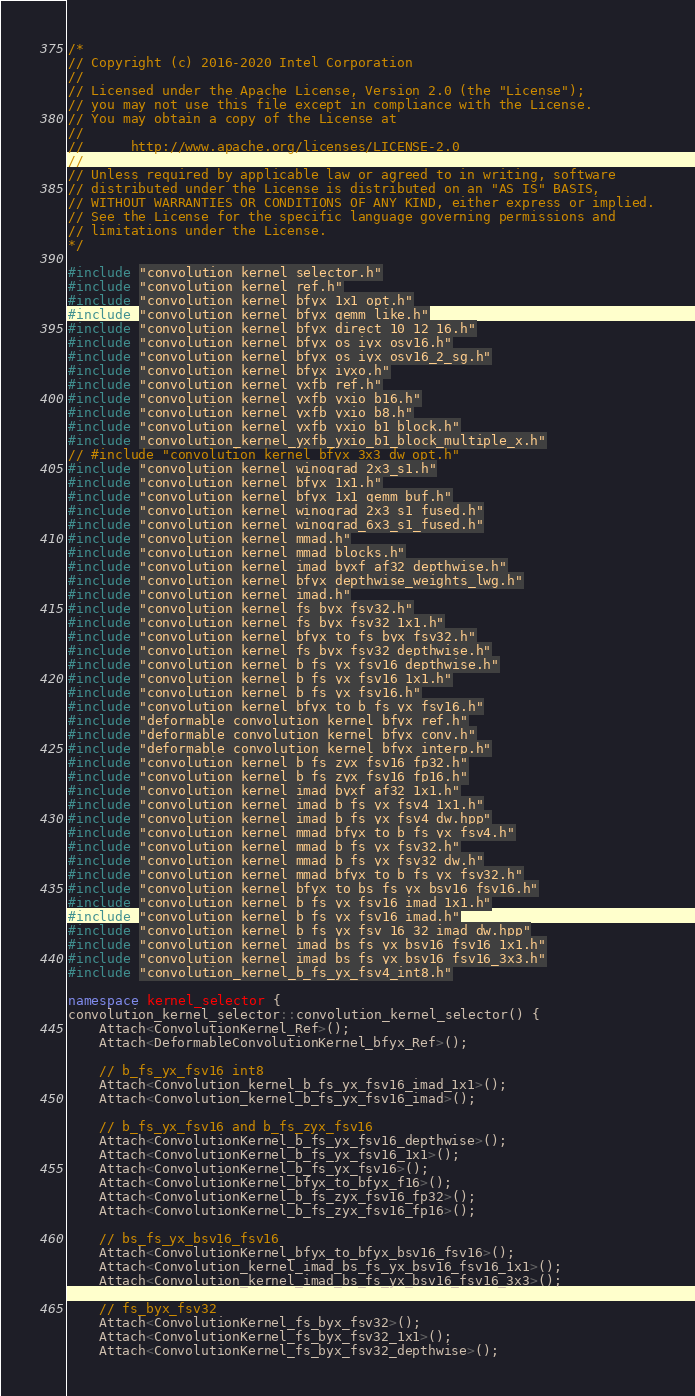Convert code to text. <code><loc_0><loc_0><loc_500><loc_500><_C++_>/*
// Copyright (c) 2016-2020 Intel Corporation
//
// Licensed under the Apache License, Version 2.0 (the "License");
// you may not use this file except in compliance with the License.
// You may obtain a copy of the License at
//
//      http://www.apache.org/licenses/LICENSE-2.0
//
// Unless required by applicable law or agreed to in writing, software
// distributed under the License is distributed on an "AS IS" BASIS,
// WITHOUT WARRANTIES OR CONDITIONS OF ANY KIND, either express or implied.
// See the License for the specific language governing permissions and
// limitations under the License.
*/

#include "convolution_kernel_selector.h"
#include "convolution_kernel_ref.h"
#include "convolution_kernel_bfyx_1x1_opt.h"
#include "convolution_kernel_bfyx_gemm_like.h"
#include "convolution_kernel_bfyx_direct_10_12_16.h"
#include "convolution_kernel_bfyx_os_iyx_osv16.h"
#include "convolution_kernel_bfyx_os_iyx_osv16_2_sg.h"
#include "convolution_kernel_bfyx_iyxo.h"
#include "convolution_kernel_yxfb_ref.h"
#include "convolution_kernel_yxfb_yxio_b16.h"
#include "convolution_kernel_yxfb_yxio_b8.h"
#include "convolution_kernel_yxfb_yxio_b1_block.h"
#include "convolution_kernel_yxfb_yxio_b1_block_multiple_x.h"
// #include "convolution_kernel_bfyx_3x3_dw_opt.h"
#include "convolution_kernel_winograd_2x3_s1.h"
#include "convolution_kernel_bfyx_1x1.h"
#include "convolution_kernel_bfyx_1x1_gemm_buf.h"
#include "convolution_kernel_winograd_2x3_s1_fused.h"
#include "convolution_kernel_winograd_6x3_s1_fused.h"
#include "convolution_kernel_mmad.h"
#include "convolution_kernel_mmad_blocks.h"
#include "convolution_kernel_imad_byxf_af32_depthwise.h"
#include "convolution_kernel_bfyx_depthwise_weights_lwg.h"
#include "convolution_kernel_imad.h"
#include "convolution_kernel_fs_byx_fsv32.h"
#include "convolution_kernel_fs_byx_fsv32_1x1.h"
#include "convolution_kernel_bfyx_to_fs_byx_fsv32.h"
#include "convolution_kernel_fs_byx_fsv32_depthwise.h"
#include "convolution_kernel_b_fs_yx_fsv16_depthwise.h"
#include "convolution_kernel_b_fs_yx_fsv16_1x1.h"
#include "convolution_kernel_b_fs_yx_fsv16.h"
#include "convolution_kernel_bfyx_to_b_fs_yx_fsv16.h"
#include "deformable_convolution_kernel_bfyx_ref.h"
#include "deformable_convolution_kernel_bfyx_conv.h"
#include "deformable_convolution_kernel_bfyx_interp.h"
#include "convolution_kernel_b_fs_zyx_fsv16_fp32.h"
#include "convolution_kernel_b_fs_zyx_fsv16_fp16.h"
#include "convolution_kernel_imad_byxf_af32_1x1.h"
#include "convolution_kernel_imad_b_fs_yx_fsv4_1x1.h"
#include "convolution_kernel_imad_b_fs_yx_fsv4_dw.hpp"
#include "convolution_kernel_mmad_bfyx_to_b_fs_yx_fsv4.h"
#include "convolution_kernel_mmad_b_fs_yx_fsv32.h"
#include "convolution_kernel_mmad_b_fs_yx_fsv32_dw.h"
#include "convolution_kernel_mmad_bfyx_to_b_fs_yx_fsv32.h"
#include "convolution_kernel_bfyx_to_bs_fs_yx_bsv16_fsv16.h"
#include "convolution_kernel_b_fs_yx_fsv16_imad_1x1.h"
#include "convolution_kernel_b_fs_yx_fsv16_imad.h"
#include "convolution_kernel_b_fs_yx_fsv_16_32_imad_dw.hpp"
#include "convolution_kernel_imad_bs_fs_yx_bsv16_fsv16_1x1.h"
#include "convolution_kernel_imad_bs_fs_yx_bsv16_fsv16_3x3.h"
#include "convolution_kernel_b_fs_yx_fsv4_int8.h"

namespace kernel_selector {
convolution_kernel_selector::convolution_kernel_selector() {
    Attach<ConvolutionKernel_Ref>();
    Attach<DeformableConvolutionKernel_bfyx_Ref>();

    // b_fs_yx_fsv16 int8
    Attach<Convolution_kernel_b_fs_yx_fsv16_imad_1x1>();
    Attach<Convolution_kernel_b_fs_yx_fsv16_imad>();

    // b_fs_yx_fsv16 and b_fs_zyx_fsv16
    Attach<ConvolutionKernel_b_fs_yx_fsv16_depthwise>();
    Attach<ConvolutionKernel_b_fs_yx_fsv16_1x1>();
    Attach<ConvolutionKernel_b_fs_yx_fsv16>();
    Attach<ConvolutionKernel_bfyx_to_bfyx_f16>();
    Attach<ConvolutionKernel_b_fs_zyx_fsv16_fp32>();
    Attach<ConvolutionKernel_b_fs_zyx_fsv16_fp16>();

    // bs_fs_yx_bsv16_fsv16
    Attach<ConvolutionKernel_bfyx_to_bfyx_bsv16_fsv16>();
    Attach<Convolution_kernel_imad_bs_fs_yx_bsv16_fsv16_1x1>();
    Attach<Convolution_kernel_imad_bs_fs_yx_bsv16_fsv16_3x3>();

    // fs_byx_fsv32
    Attach<ConvolutionKernel_fs_byx_fsv32>();
    Attach<ConvolutionKernel_fs_byx_fsv32_1x1>();
    Attach<ConvolutionKernel_fs_byx_fsv32_depthwise>();</code> 